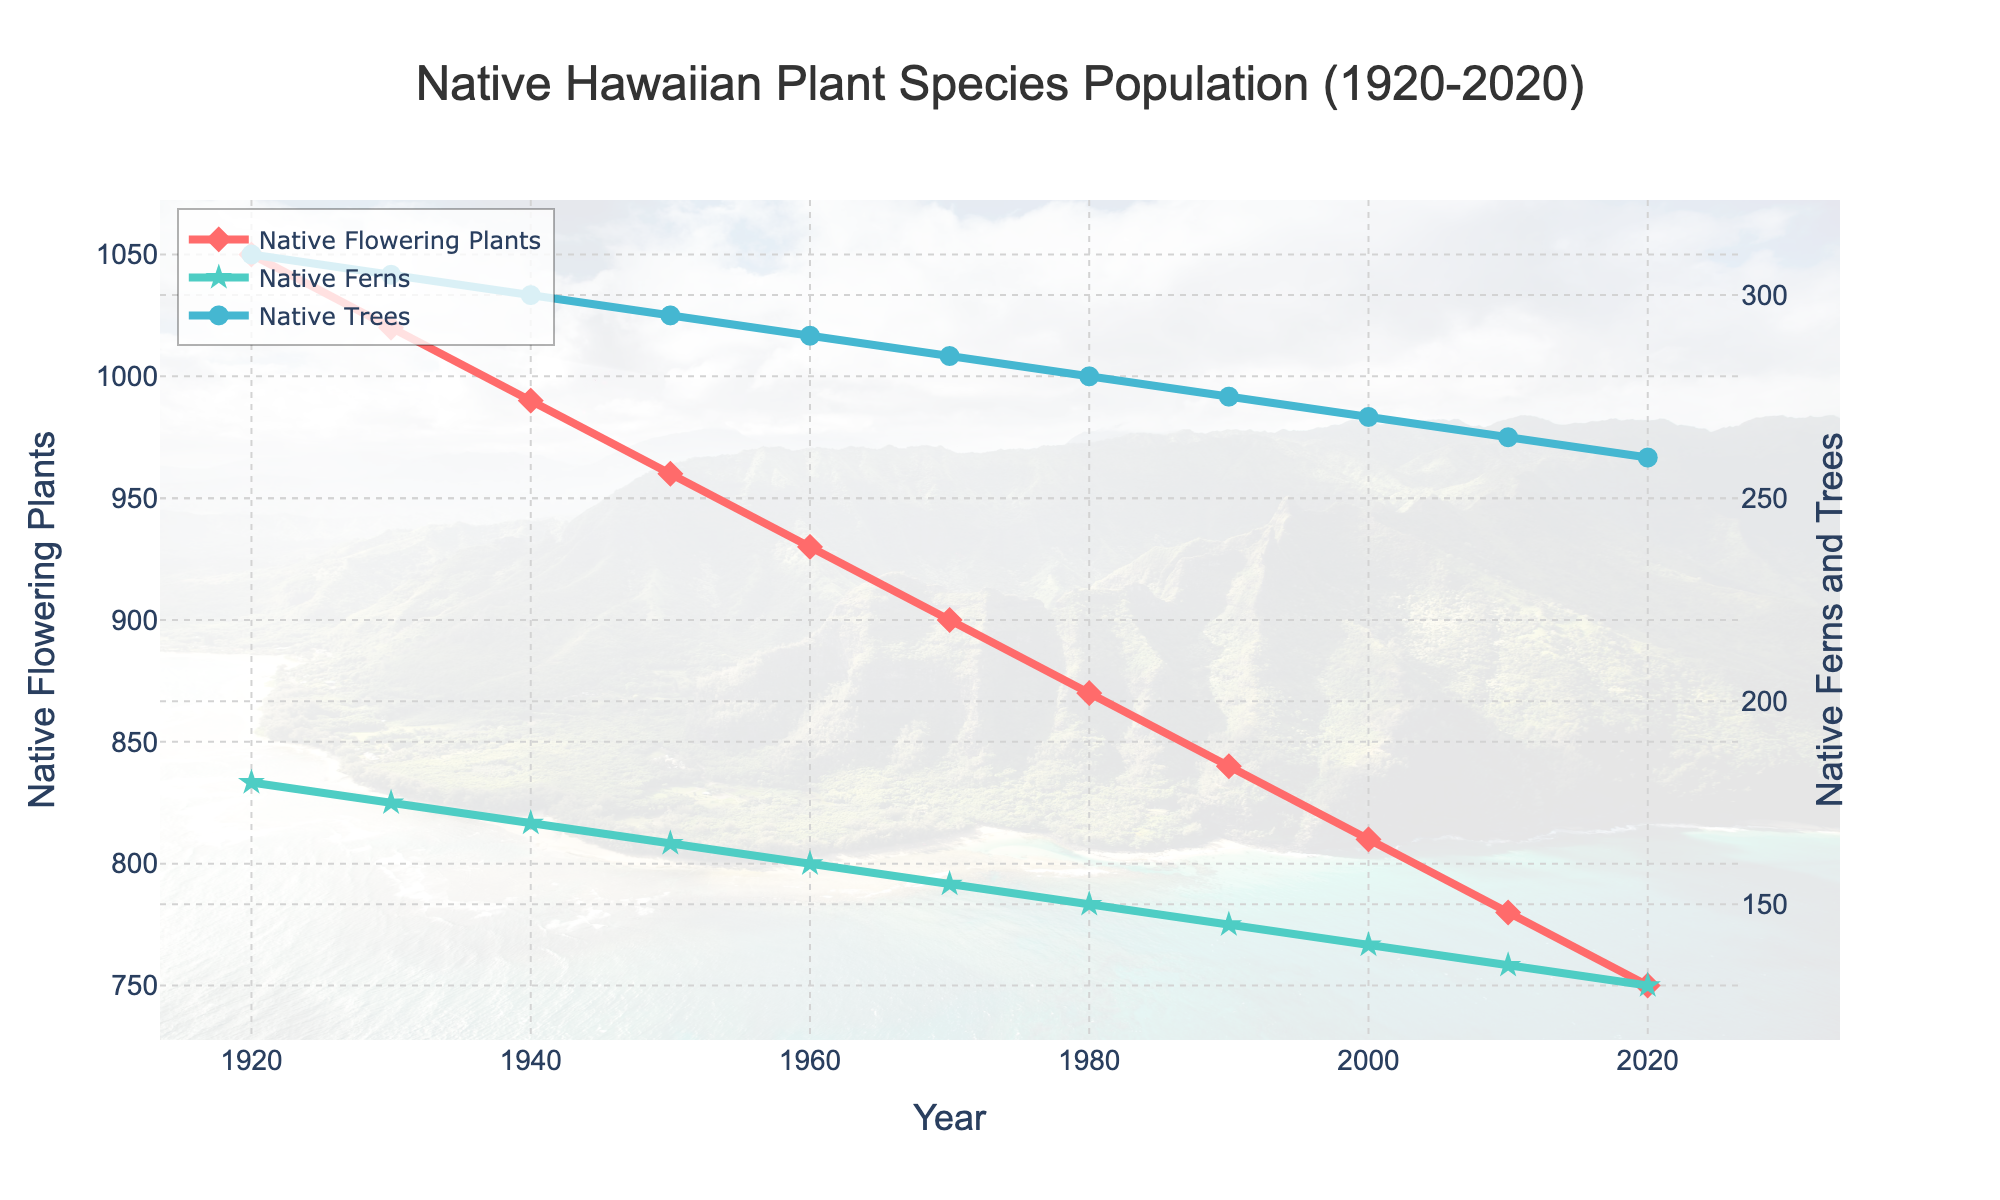What is the rate of decline for Native Flowering Plants between 1920 and 2020? Between 1920 and 2020, the population of Native Flowering Plants decreased from 1050 to 750. The difference is 1050 - 750 = 300. Dividing the difference by the number of years (2020 - 1920 = 100) gives the rate of decline, which is 300 / 100 = 3 plants per year.
Answer: 3 plants per year Which category of plant species experienced the least decline over the century? By observing the lines, it's clear that all categories are declining, but we need to calculate the differences for each: Flowering Plants: 1050 - 750 = 300, Ferns: 180 - 130 = 50, Trees: 310 - 260 = 50. Both Native Ferns and Trees had the least decline of 50.
Answer: Native Ferns and Trees What is the difference in populations between Native Ferns and Native Trees in 2020? From the data, in 2020, Native Ferns are at 130 and Native Trees are at 260. The difference is 260 - 130 = 130.
Answer: 130 In what year did the Native Flowering Plants population first drop below 900? By reviewing the figure, in 1970, the Native Flowering Plants population was 900, and in 1980, it was 870. Therefore, the first year it dropped below 900 was 1980.
Answer: 1980 What is the combined population of all native plants in 1950? From the data, in 1950, Native Flowering Plants = 960, Native Ferns = 165, Native Trees = 295. The total combined is 960 + 165 + 295 = 1420.
Answer: 1420 Compare the average annual decrease in the population of Native Ferns and Native Trees from 1920 to 2020. Which has a higher average annual decrease? For Native Ferns: Initial population was 180, and the final was 130. Difference = 180 - 130 = 50 over 100 years, thus 50/100 = 0.5 per year. For Native Trees: Initial population was 310, and the final was 260. Difference = 310 - 260 = 50 over 100 years, thus 50/100 = 0.5 per year. Both have the same average annual decrease.
Answer: Same (0.5 per year) What visual elements differentiate the plot lines for Native Ferns and Native Trees? The plot line for Native Ferns is green with star markers, while the plot line for Native Trees is blue with circle markers.
Answer: Different colors and marker shapes 